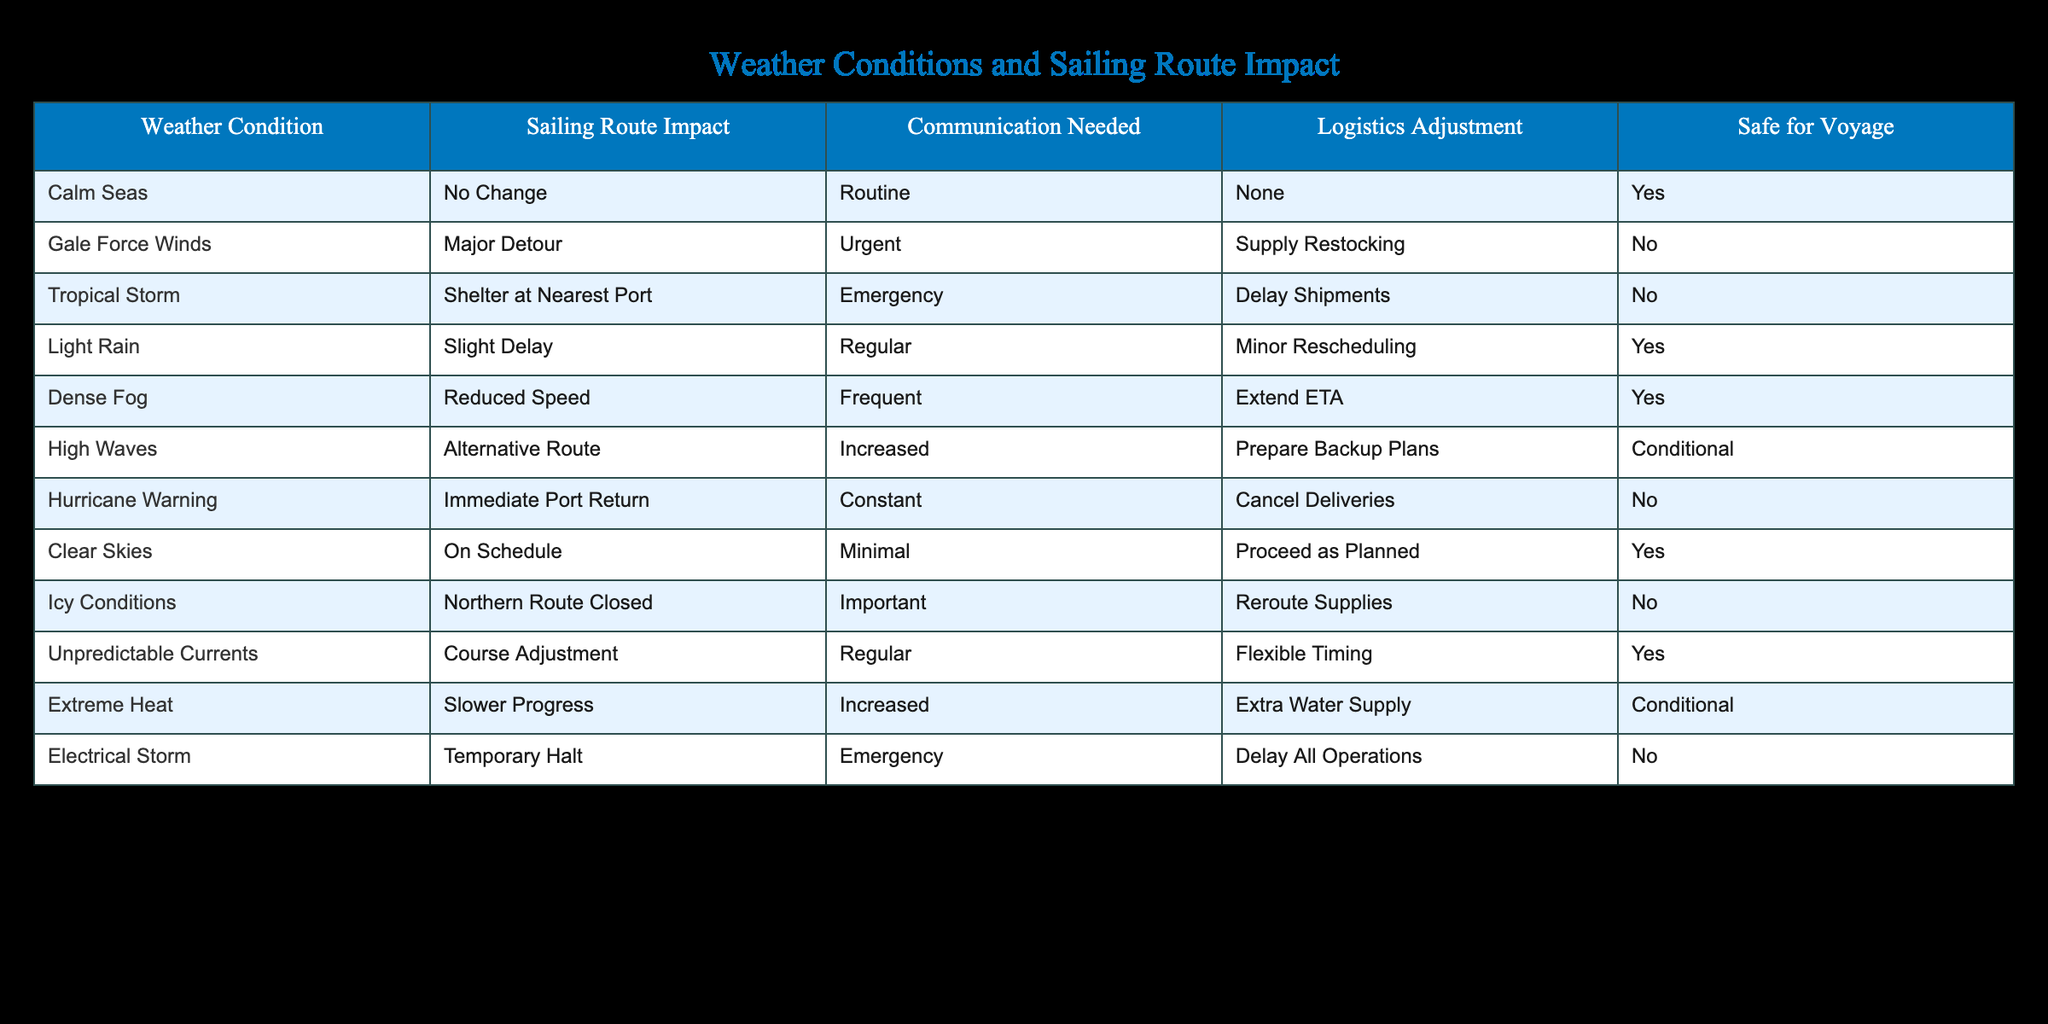What impact do Gale Force Winds have on sailing routes? Gale Force Winds cause a major detour on sailing routes according to the table, which is a direct retrieval from the "Sailing Route Impact" column for this weather condition.
Answer: Major Detour Is it safe to sail when there is a Tropical Storm? The table states that in the case of a Tropical Storm, the safe for voyage column indicates "No," which directly answers the question about safety during this weather condition.
Answer: No How many weather conditions require urgent communication? By examining the "Communication Needed" column, I see that both Gale Force Winds (Urgent) and Tropical Storm (Emergency) require urgent communication, totaling 2 conditions.
Answer: 2 What logistics adjustments are needed for Icy Conditions? The table specifies that for Icy Conditions, the logistics adjustment required is to reroute supplies. This is a direct retrieval from the corresponding column for this weather condition.
Answer: Reroute Supplies Can we proceed as planned if the weather shows Clear Skies? Yes, according to the table, under Clear Skies, it is marked as "Safe for Voyage," indicating that it is safe to proceed as planned for sailing.
Answer: Yes What are the safe sailing conditions that do not require any logistics adjustments? The table shows that Calm Seas, Light Rain, Dense Fog, and Clear Skies fall under safe conditions without logistics adjustments, which total to four conditions when counted.
Answer: 4 If sailing in Extreme Heat, what preparations are needed? Extreme Heat requires an increased supply of water, according to the logistics adjustment noted in the table. This is directly derived from the respective row for that weather condition.
Answer: Extra Water Supply Are there any weather conditions that necessitate both emergency communication and logistics adjustments? Both Tropical Storm and Electrical Storm are the only conditions that require emergency communication, but only Tropical Storm calls for a logistics adjustment (Delay Shipments), making it the only one fitting this criterion.
Answer: Yes, Tropical Storm What can be deduced about sailing routes when faced with Dense Fog? The table indicates that Dense Fog leads to reduced speed necessitating frequent communication and the adjustment of extending the estimated time of arrival (ETA). This reflects the need for caution.
Answer: Caution is needed 